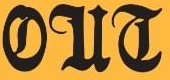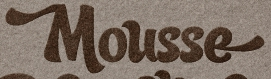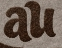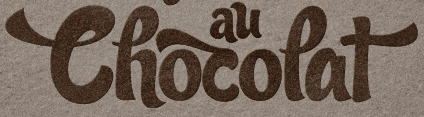What text appears in these images from left to right, separated by a semicolon? OUT; Mousse; au; Thocopat 